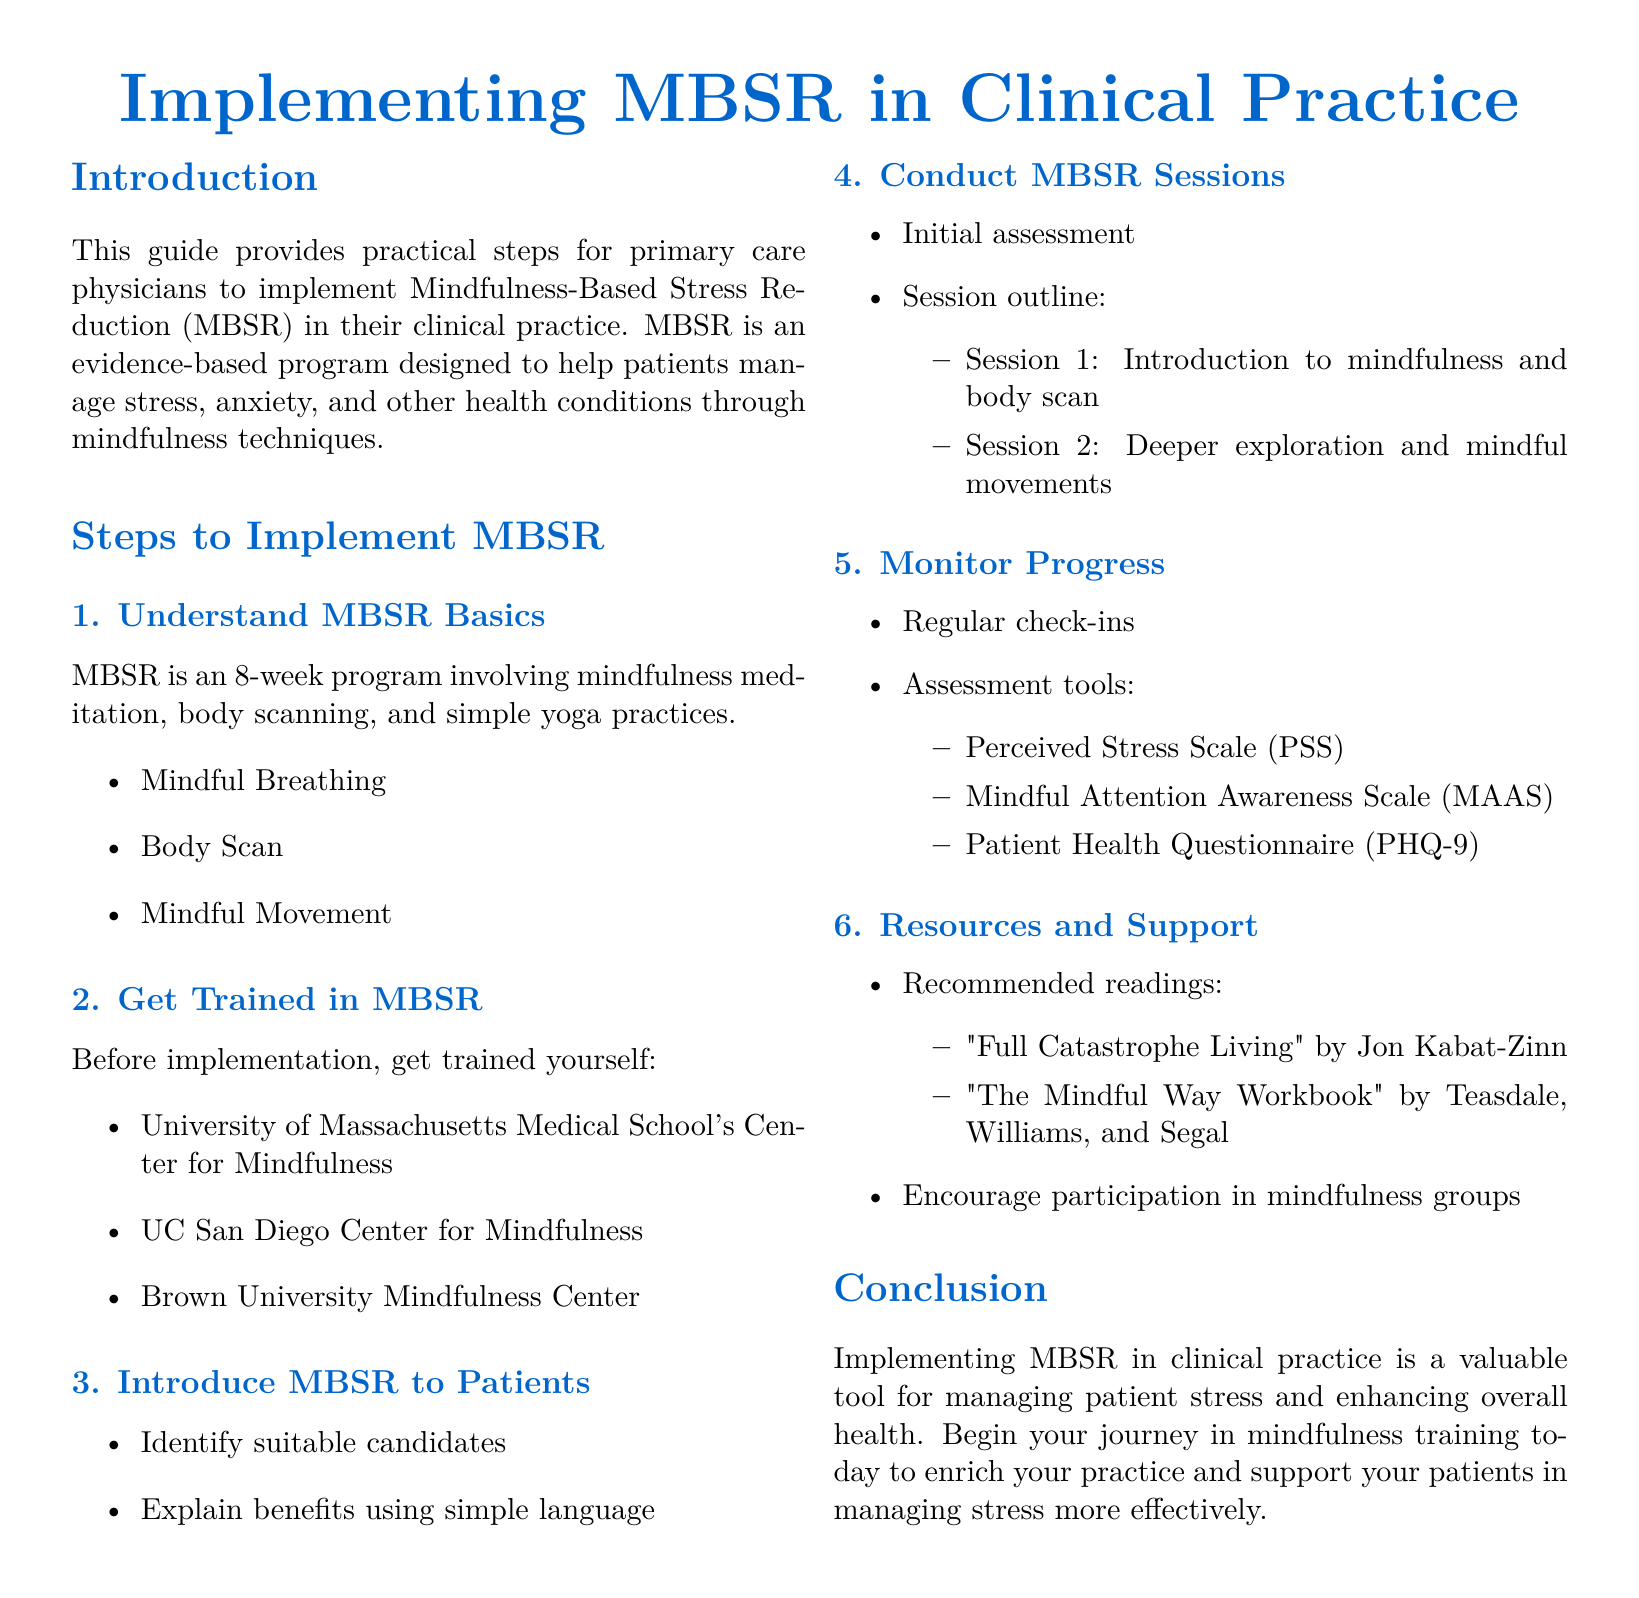What is the purpose of this guide? The purpose of the guide is to provide practical steps for primary care physicians to implement Mindfulness-Based Stress Reduction (MBSR) in their clinical practice.
Answer: To provide practical steps for implementation What are the main components of MBSR? The main components include mindfulness meditation, body scanning, and simple yoga practices as listed in the document.
Answer: Mindfulness meditation, body scanning, and simple yoga practices How long is the MBSR program? The MBSR program is described as an 8-week program in the document.
Answer: 8 weeks Name one institution where a physician can get trained in MBSR. The document lists several institutions for training; one mentioned is the University of Massachusetts Medical School's Center for Mindfulness.
Answer: University of Massachusetts Medical School's Center for Mindfulness What tool is recommended for assessing perceived stress? The document states the Perceived Stress Scale (PSS) is recommended for assessing perceived stress.
Answer: Perceived Stress Scale (PSS) What book is suggested for further reading on MBSR? The document recommends "Full Catastrophe Living" by Jon Kabat-Zinn as suggested reading.
Answer: Full Catastrophe Living What type of assessment should be conducted during MBSR sessions? The document suggests performing an initial assessment as part of conducting MBSR sessions.
Answer: Initial assessment How can progress be monitored in MBSR? Regular check-ins are mentioned in the guide as a method to monitor progress.
Answer: Regular check-ins 